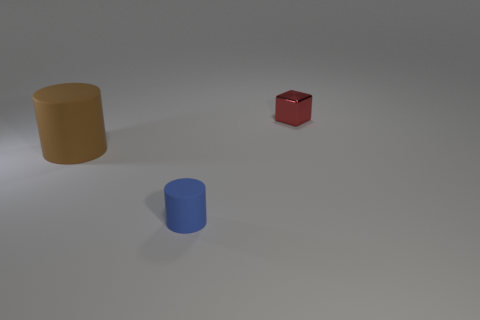Add 3 gray balls. How many objects exist? 6 Subtract all cylinders. How many objects are left? 1 Subtract 0 yellow blocks. How many objects are left? 3 Subtract all tiny metal objects. Subtract all large brown matte objects. How many objects are left? 1 Add 2 cylinders. How many cylinders are left? 4 Add 3 small objects. How many small objects exist? 5 